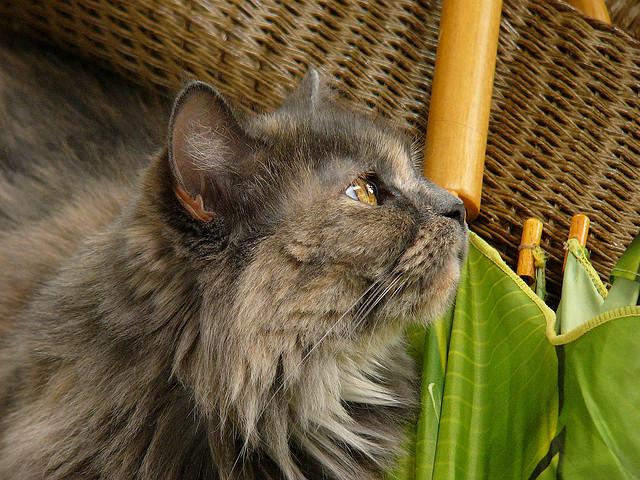Does this animal like to chase mice?
Keep it brief. Yes. Is the cats fur wet?
Quick response, please. No. What kind of animal is this?
Concise answer only. Cat. 